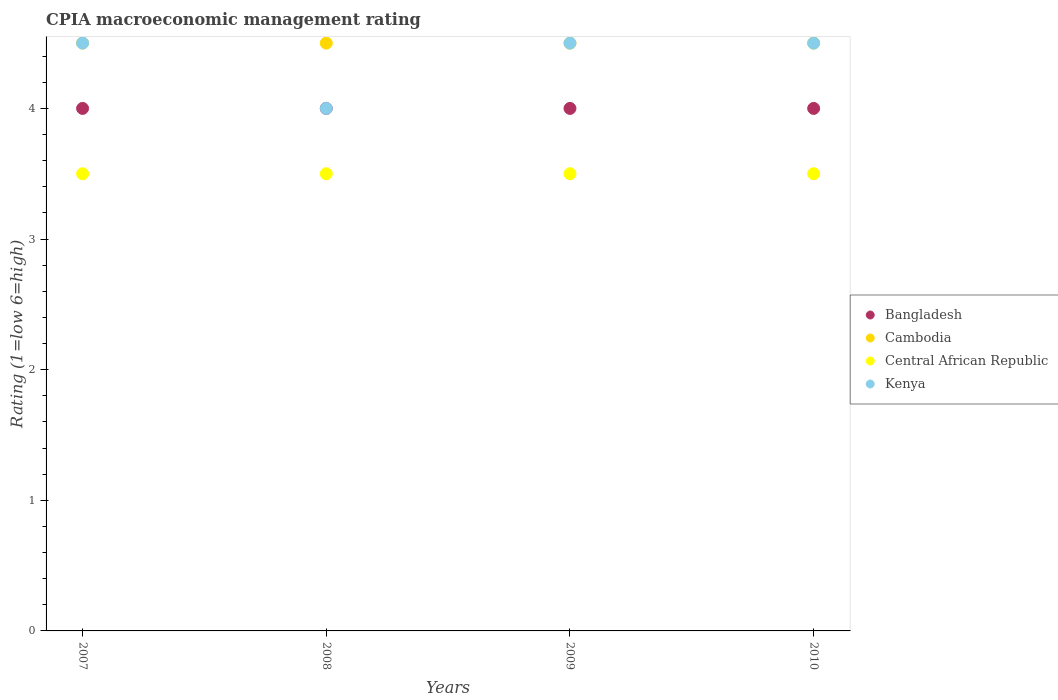Across all years, what is the maximum CPIA rating in Kenya?
Make the answer very short. 4.5. Across all years, what is the minimum CPIA rating in Bangladesh?
Offer a terse response. 4. In which year was the CPIA rating in Bangladesh maximum?
Keep it short and to the point. 2007. In which year was the CPIA rating in Cambodia minimum?
Offer a very short reply. 2007. What is the total CPIA rating in Kenya in the graph?
Keep it short and to the point. 17.5. What is the difference between the CPIA rating in Central African Republic in 2007 and that in 2008?
Keep it short and to the point. 0. In the year 2007, what is the difference between the CPIA rating in Kenya and CPIA rating in Cambodia?
Your answer should be very brief. 0. What is the ratio of the CPIA rating in Bangladesh in 2009 to that in 2010?
Offer a terse response. 1. Is the CPIA rating in Bangladesh in 2007 less than that in 2010?
Make the answer very short. No. In how many years, is the CPIA rating in Central African Republic greater than the average CPIA rating in Central African Republic taken over all years?
Ensure brevity in your answer.  0. Is it the case that in every year, the sum of the CPIA rating in Central African Republic and CPIA rating in Cambodia  is greater than the sum of CPIA rating in Kenya and CPIA rating in Bangladesh?
Make the answer very short. No. Does the CPIA rating in Bangladesh monotonically increase over the years?
Provide a succinct answer. No. Is the CPIA rating in Central African Republic strictly less than the CPIA rating in Bangladesh over the years?
Your answer should be compact. Yes. What is the difference between two consecutive major ticks on the Y-axis?
Your answer should be compact. 1. Does the graph contain any zero values?
Your response must be concise. No. Does the graph contain grids?
Give a very brief answer. No. How many legend labels are there?
Offer a very short reply. 4. What is the title of the graph?
Keep it short and to the point. CPIA macroeconomic management rating. What is the label or title of the X-axis?
Offer a very short reply. Years. What is the Rating (1=low 6=high) in Central African Republic in 2007?
Make the answer very short. 3.5. What is the Rating (1=low 6=high) in Kenya in 2007?
Provide a succinct answer. 4.5. What is the Rating (1=low 6=high) in Bangladesh in 2008?
Ensure brevity in your answer.  4. What is the Rating (1=low 6=high) of Cambodia in 2008?
Offer a terse response. 4.5. What is the Rating (1=low 6=high) in Central African Republic in 2008?
Keep it short and to the point. 3.5. What is the Rating (1=low 6=high) in Central African Republic in 2009?
Give a very brief answer. 3.5. What is the Rating (1=low 6=high) in Kenya in 2009?
Your response must be concise. 4.5. What is the Rating (1=low 6=high) in Bangladesh in 2010?
Offer a terse response. 4. What is the Rating (1=low 6=high) of Cambodia in 2010?
Keep it short and to the point. 4.5. What is the Rating (1=low 6=high) in Central African Republic in 2010?
Your response must be concise. 3.5. What is the Rating (1=low 6=high) in Kenya in 2010?
Keep it short and to the point. 4.5. Across all years, what is the maximum Rating (1=low 6=high) of Central African Republic?
Make the answer very short. 3.5. Across all years, what is the minimum Rating (1=low 6=high) of Bangladesh?
Provide a short and direct response. 4. Across all years, what is the minimum Rating (1=low 6=high) of Kenya?
Keep it short and to the point. 4. What is the total Rating (1=low 6=high) of Bangladesh in the graph?
Your answer should be compact. 16. What is the total Rating (1=low 6=high) of Cambodia in the graph?
Keep it short and to the point. 18. What is the total Rating (1=low 6=high) of Central African Republic in the graph?
Your answer should be compact. 14. What is the total Rating (1=low 6=high) of Kenya in the graph?
Your response must be concise. 17.5. What is the difference between the Rating (1=low 6=high) of Cambodia in 2007 and that in 2008?
Offer a very short reply. 0. What is the difference between the Rating (1=low 6=high) of Central African Republic in 2007 and that in 2008?
Make the answer very short. 0. What is the difference between the Rating (1=low 6=high) in Bangladesh in 2007 and that in 2009?
Give a very brief answer. 0. What is the difference between the Rating (1=low 6=high) in Cambodia in 2007 and that in 2009?
Keep it short and to the point. 0. What is the difference between the Rating (1=low 6=high) of Cambodia in 2007 and that in 2010?
Give a very brief answer. 0. What is the difference between the Rating (1=low 6=high) in Central African Republic in 2007 and that in 2010?
Provide a succinct answer. 0. What is the difference between the Rating (1=low 6=high) in Kenya in 2007 and that in 2010?
Your answer should be very brief. 0. What is the difference between the Rating (1=low 6=high) in Bangladesh in 2008 and that in 2009?
Offer a terse response. 0. What is the difference between the Rating (1=low 6=high) in Cambodia in 2008 and that in 2009?
Provide a succinct answer. 0. What is the difference between the Rating (1=low 6=high) in Central African Republic in 2008 and that in 2009?
Offer a terse response. 0. What is the difference between the Rating (1=low 6=high) in Kenya in 2008 and that in 2009?
Keep it short and to the point. -0.5. What is the difference between the Rating (1=low 6=high) of Bangladesh in 2008 and that in 2010?
Keep it short and to the point. 0. What is the difference between the Rating (1=low 6=high) in Cambodia in 2008 and that in 2010?
Give a very brief answer. 0. What is the difference between the Rating (1=low 6=high) in Central African Republic in 2008 and that in 2010?
Your response must be concise. 0. What is the difference between the Rating (1=low 6=high) of Bangladesh in 2009 and that in 2010?
Offer a very short reply. 0. What is the difference between the Rating (1=low 6=high) in Cambodia in 2009 and that in 2010?
Offer a very short reply. 0. What is the difference between the Rating (1=low 6=high) of Bangladesh in 2007 and the Rating (1=low 6=high) of Cambodia in 2008?
Your response must be concise. -0.5. What is the difference between the Rating (1=low 6=high) in Bangladesh in 2007 and the Rating (1=low 6=high) in Cambodia in 2009?
Keep it short and to the point. -0.5. What is the difference between the Rating (1=low 6=high) in Cambodia in 2007 and the Rating (1=low 6=high) in Central African Republic in 2009?
Provide a succinct answer. 1. What is the difference between the Rating (1=low 6=high) of Central African Republic in 2007 and the Rating (1=low 6=high) of Kenya in 2009?
Keep it short and to the point. -1. What is the difference between the Rating (1=low 6=high) in Cambodia in 2007 and the Rating (1=low 6=high) in Central African Republic in 2010?
Your response must be concise. 1. What is the difference between the Rating (1=low 6=high) in Cambodia in 2007 and the Rating (1=low 6=high) in Kenya in 2010?
Ensure brevity in your answer.  0. What is the difference between the Rating (1=low 6=high) of Bangladesh in 2008 and the Rating (1=low 6=high) of Cambodia in 2009?
Offer a very short reply. -0.5. What is the difference between the Rating (1=low 6=high) of Bangladesh in 2008 and the Rating (1=low 6=high) of Central African Republic in 2009?
Offer a terse response. 0.5. What is the difference between the Rating (1=low 6=high) of Cambodia in 2008 and the Rating (1=low 6=high) of Kenya in 2009?
Ensure brevity in your answer.  0. What is the difference between the Rating (1=low 6=high) in Bangladesh in 2008 and the Rating (1=low 6=high) in Cambodia in 2010?
Provide a short and direct response. -0.5. What is the difference between the Rating (1=low 6=high) of Central African Republic in 2008 and the Rating (1=low 6=high) of Kenya in 2010?
Keep it short and to the point. -1. What is the difference between the Rating (1=low 6=high) in Bangladesh in 2009 and the Rating (1=low 6=high) in Central African Republic in 2010?
Your response must be concise. 0.5. What is the difference between the Rating (1=low 6=high) of Central African Republic in 2009 and the Rating (1=low 6=high) of Kenya in 2010?
Provide a short and direct response. -1. What is the average Rating (1=low 6=high) of Central African Republic per year?
Your answer should be very brief. 3.5. What is the average Rating (1=low 6=high) of Kenya per year?
Give a very brief answer. 4.38. In the year 2007, what is the difference between the Rating (1=low 6=high) in Bangladesh and Rating (1=low 6=high) in Cambodia?
Give a very brief answer. -0.5. In the year 2007, what is the difference between the Rating (1=low 6=high) in Bangladesh and Rating (1=low 6=high) in Kenya?
Ensure brevity in your answer.  -0.5. In the year 2007, what is the difference between the Rating (1=low 6=high) in Cambodia and Rating (1=low 6=high) in Kenya?
Offer a terse response. 0. In the year 2007, what is the difference between the Rating (1=low 6=high) of Central African Republic and Rating (1=low 6=high) of Kenya?
Make the answer very short. -1. In the year 2008, what is the difference between the Rating (1=low 6=high) of Bangladesh and Rating (1=low 6=high) of Cambodia?
Ensure brevity in your answer.  -0.5. In the year 2008, what is the difference between the Rating (1=low 6=high) of Bangladesh and Rating (1=low 6=high) of Central African Republic?
Your response must be concise. 0.5. In the year 2008, what is the difference between the Rating (1=low 6=high) in Cambodia and Rating (1=low 6=high) in Central African Republic?
Give a very brief answer. 1. In the year 2009, what is the difference between the Rating (1=low 6=high) of Bangladesh and Rating (1=low 6=high) of Central African Republic?
Ensure brevity in your answer.  0.5. In the year 2009, what is the difference between the Rating (1=low 6=high) of Bangladesh and Rating (1=low 6=high) of Kenya?
Your answer should be very brief. -0.5. In the year 2009, what is the difference between the Rating (1=low 6=high) in Cambodia and Rating (1=low 6=high) in Kenya?
Keep it short and to the point. 0. In the year 2009, what is the difference between the Rating (1=low 6=high) in Central African Republic and Rating (1=low 6=high) in Kenya?
Offer a terse response. -1. In the year 2010, what is the difference between the Rating (1=low 6=high) in Bangladesh and Rating (1=low 6=high) in Cambodia?
Give a very brief answer. -0.5. In the year 2010, what is the difference between the Rating (1=low 6=high) of Cambodia and Rating (1=low 6=high) of Kenya?
Provide a succinct answer. 0. In the year 2010, what is the difference between the Rating (1=low 6=high) of Central African Republic and Rating (1=low 6=high) of Kenya?
Offer a terse response. -1. What is the ratio of the Rating (1=low 6=high) of Bangladesh in 2007 to that in 2008?
Give a very brief answer. 1. What is the ratio of the Rating (1=low 6=high) of Bangladesh in 2007 to that in 2009?
Your response must be concise. 1. What is the ratio of the Rating (1=low 6=high) in Kenya in 2007 to that in 2009?
Provide a succinct answer. 1. What is the ratio of the Rating (1=low 6=high) of Central African Republic in 2008 to that in 2009?
Offer a very short reply. 1. What is the ratio of the Rating (1=low 6=high) of Kenya in 2008 to that in 2009?
Give a very brief answer. 0.89. What is the ratio of the Rating (1=low 6=high) of Kenya in 2008 to that in 2010?
Ensure brevity in your answer.  0.89. What is the ratio of the Rating (1=low 6=high) in Cambodia in 2009 to that in 2010?
Offer a very short reply. 1. What is the ratio of the Rating (1=low 6=high) of Kenya in 2009 to that in 2010?
Ensure brevity in your answer.  1. What is the difference between the highest and the second highest Rating (1=low 6=high) in Bangladesh?
Give a very brief answer. 0. What is the difference between the highest and the second highest Rating (1=low 6=high) in Central African Republic?
Give a very brief answer. 0. What is the difference between the highest and the second highest Rating (1=low 6=high) of Kenya?
Offer a very short reply. 0. 